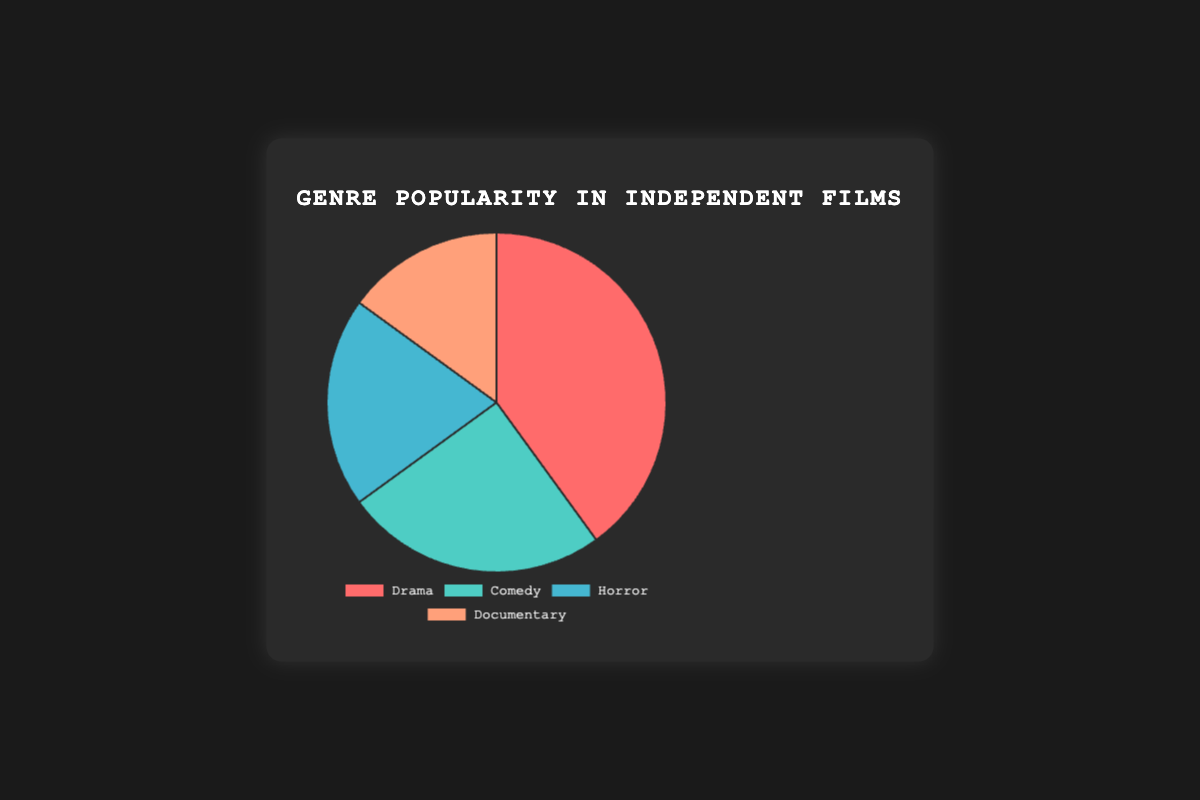Which genre is the most popular in independent films? The most popular genre is identified by the highest percentage in the pie chart. Drama has the highest percentage at 40%.
Answer: Drama What is the combined percentage of Comedy and Documentary genres? Sum up the percentages of Comedy (25%) and Documentary (15%). 25% + 15% = 40%.
Answer: 40% Which genre is the least popular, and what is its percentage? The least popular genre is identified by the lowest percentage in the pie chart. Documentary has the lowest percentage at 15%.
Answer: Documentary, 15% How much more popular is Drama compared to Horror? Subtract the percentage of Horror (20%) from Drama (40%). 40% - 20% = 20%.
Answer: 20% What is the difference in popularity between Comedy and Horror? Subtract the percentage of Horror (20%) from Comedy (25%). 25% - 20% = 5%.
Answer: 5% Can you list the genres in descending order of their popularity? Arrange the genres based on their percentages from highest to lowest. Drama (40%), Comedy (25%), Horror (20%), Documentary (15%).
Answer: Drama, Comedy, Horror, Documentary What is the total percentage of the three least popular genres combined? Sum up the percentages of Comedy (25%), Horror (20%), and Documentary (15%). 25% + 20% + 15% = 60%.
Answer: 60% If another genre was added with an 10% share, what would the new percentage for Drama be if it remains the same in value? The new total percentage is 100% + 10% = 110%. The share of Drama in the new total would be (40/110) * 100%.
Answer: 36.36% What percentage of the genres are not Drama? Subtract the percentage of Drama (40%) from the total. 100% - 40% = 60%.
Answer: 60% Which genre color is used for Documentary and what proportion does it represent? Identify the color associated with Documentary in the pie chart legend. Documentary is associated with a light salmon color and represents 15%.
Answer: Light Salmon, 15% 